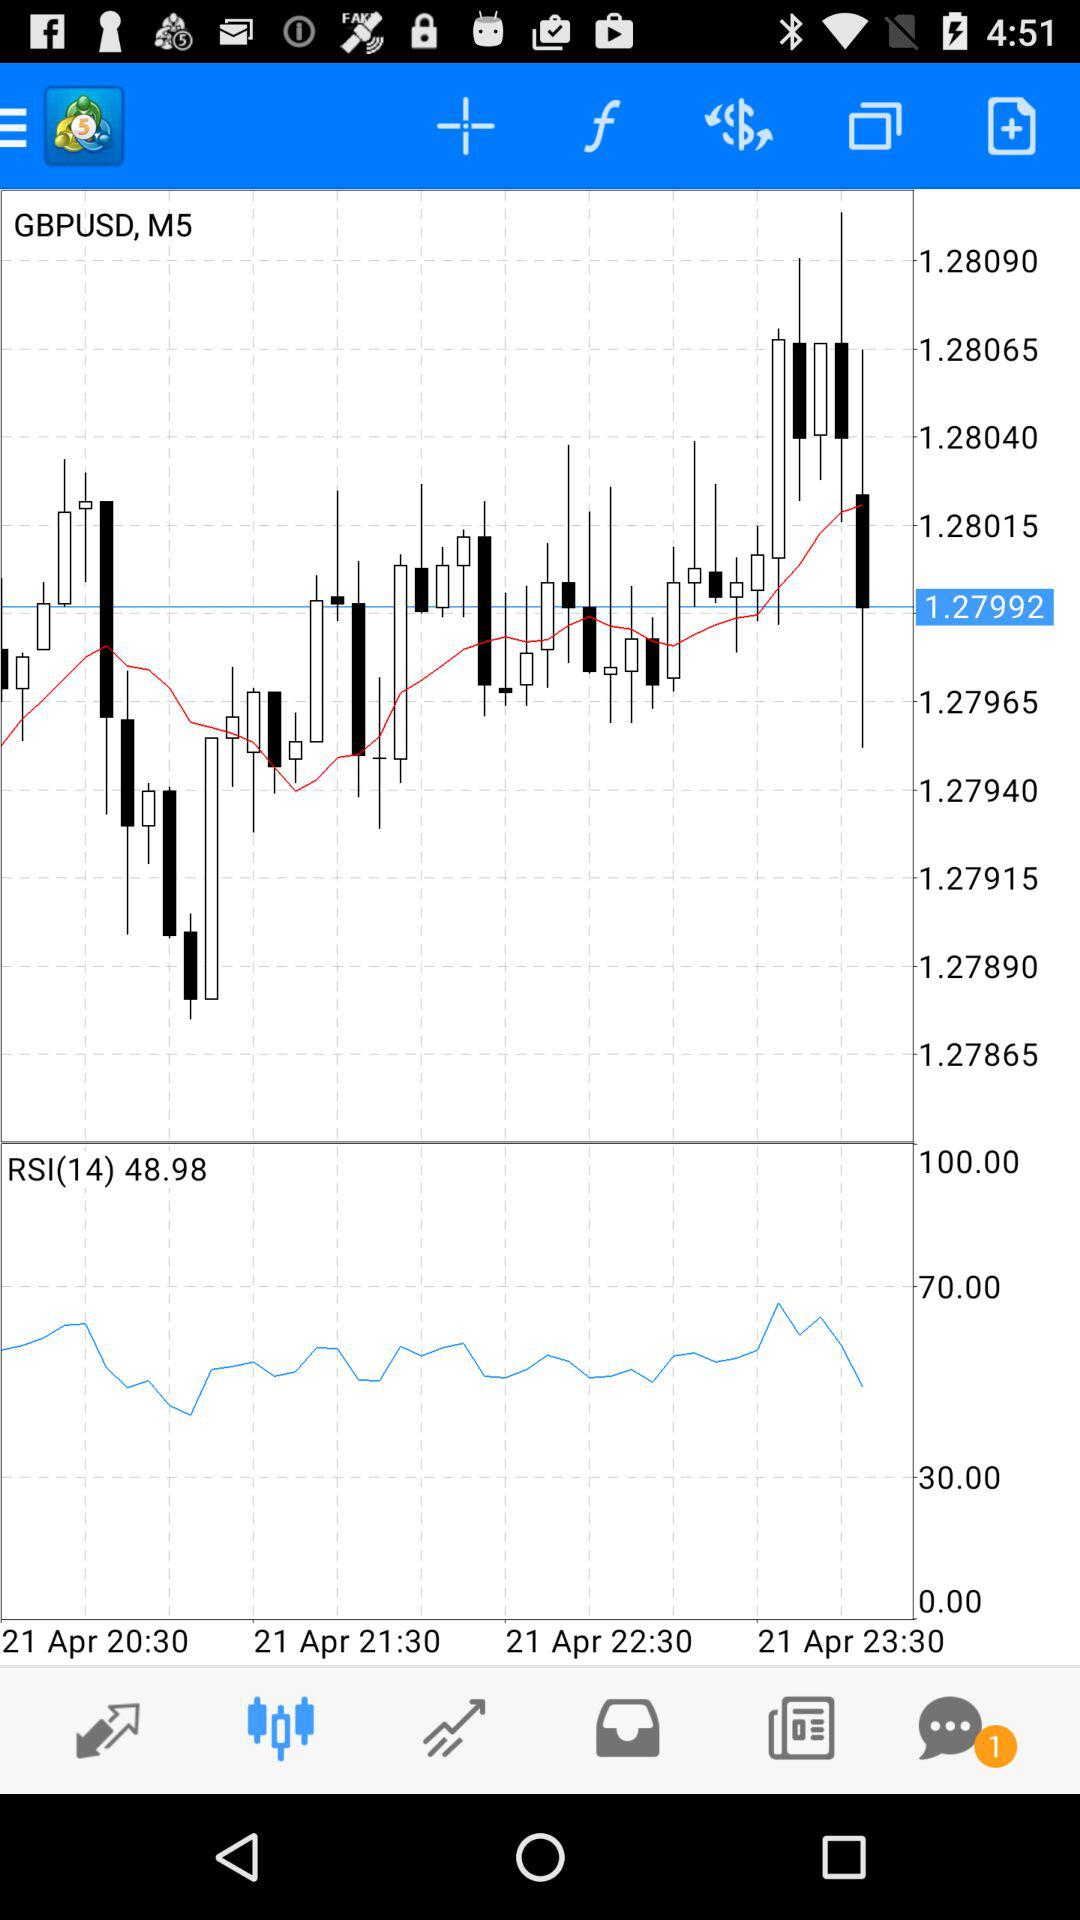What date is displayed on the screen? The displayed date is April 21. 